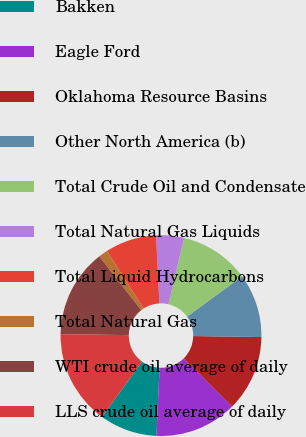Convert chart. <chart><loc_0><loc_0><loc_500><loc_500><pie_chart><fcel>Bakken<fcel>Eagle Ford<fcel>Oklahoma Resource Basins<fcel>Other North America (b)<fcel>Total Crude Oil and Condensate<fcel>Total Natural Gas Liquids<fcel>Total Liquid Hydrocarbons<fcel>Total Natural Gas<fcel>WTI crude oil average of daily<fcel>LLS crude oil average of daily<nl><fcel>9.28%<fcel>13.24%<fcel>12.25%<fcel>10.27%<fcel>11.26%<fcel>4.49%<fcel>8.28%<fcel>1.47%<fcel>14.23%<fcel>15.23%<nl></chart> 